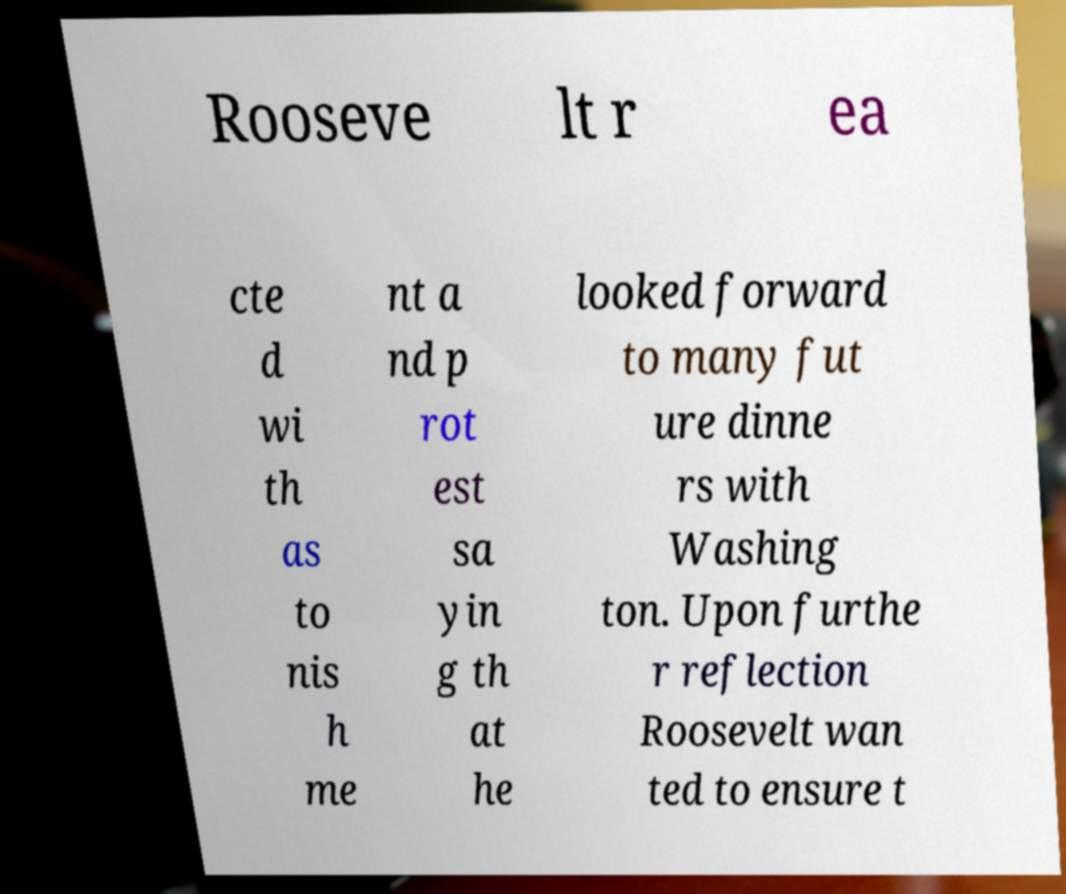Could you assist in decoding the text presented in this image and type it out clearly? Rooseve lt r ea cte d wi th as to nis h me nt a nd p rot est sa yin g th at he looked forward to many fut ure dinne rs with Washing ton. Upon furthe r reflection Roosevelt wan ted to ensure t 